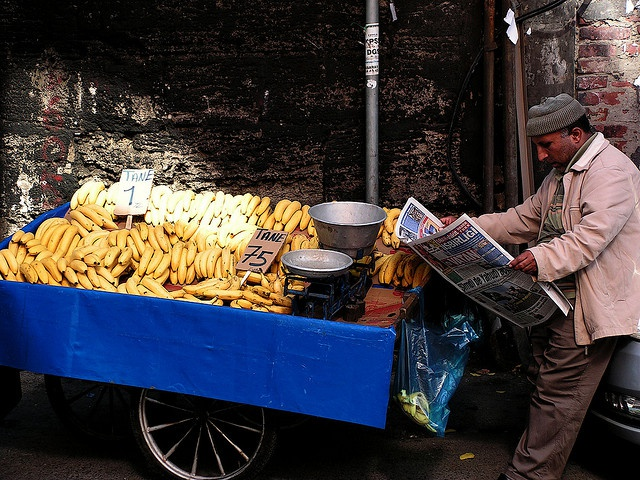Describe the objects in this image and their specific colors. I can see people in black, lightpink, maroon, and darkgray tones, banana in black, gold, orange, beige, and khaki tones, car in black, gray, and darkgray tones, bowl in black, darkgray, and lightgray tones, and bowl in black, darkgray, lightgray, and gray tones in this image. 